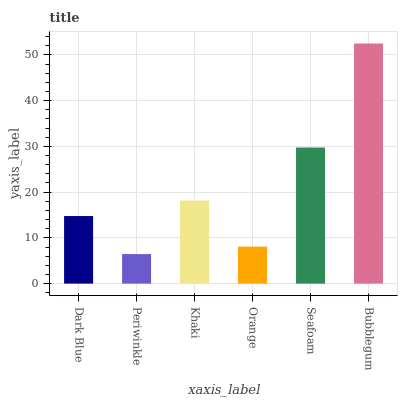Is Periwinkle the minimum?
Answer yes or no. Yes. Is Bubblegum the maximum?
Answer yes or no. Yes. Is Khaki the minimum?
Answer yes or no. No. Is Khaki the maximum?
Answer yes or no. No. Is Khaki greater than Periwinkle?
Answer yes or no. Yes. Is Periwinkle less than Khaki?
Answer yes or no. Yes. Is Periwinkle greater than Khaki?
Answer yes or no. No. Is Khaki less than Periwinkle?
Answer yes or no. No. Is Khaki the high median?
Answer yes or no. Yes. Is Dark Blue the low median?
Answer yes or no. Yes. Is Dark Blue the high median?
Answer yes or no. No. Is Seafoam the low median?
Answer yes or no. No. 